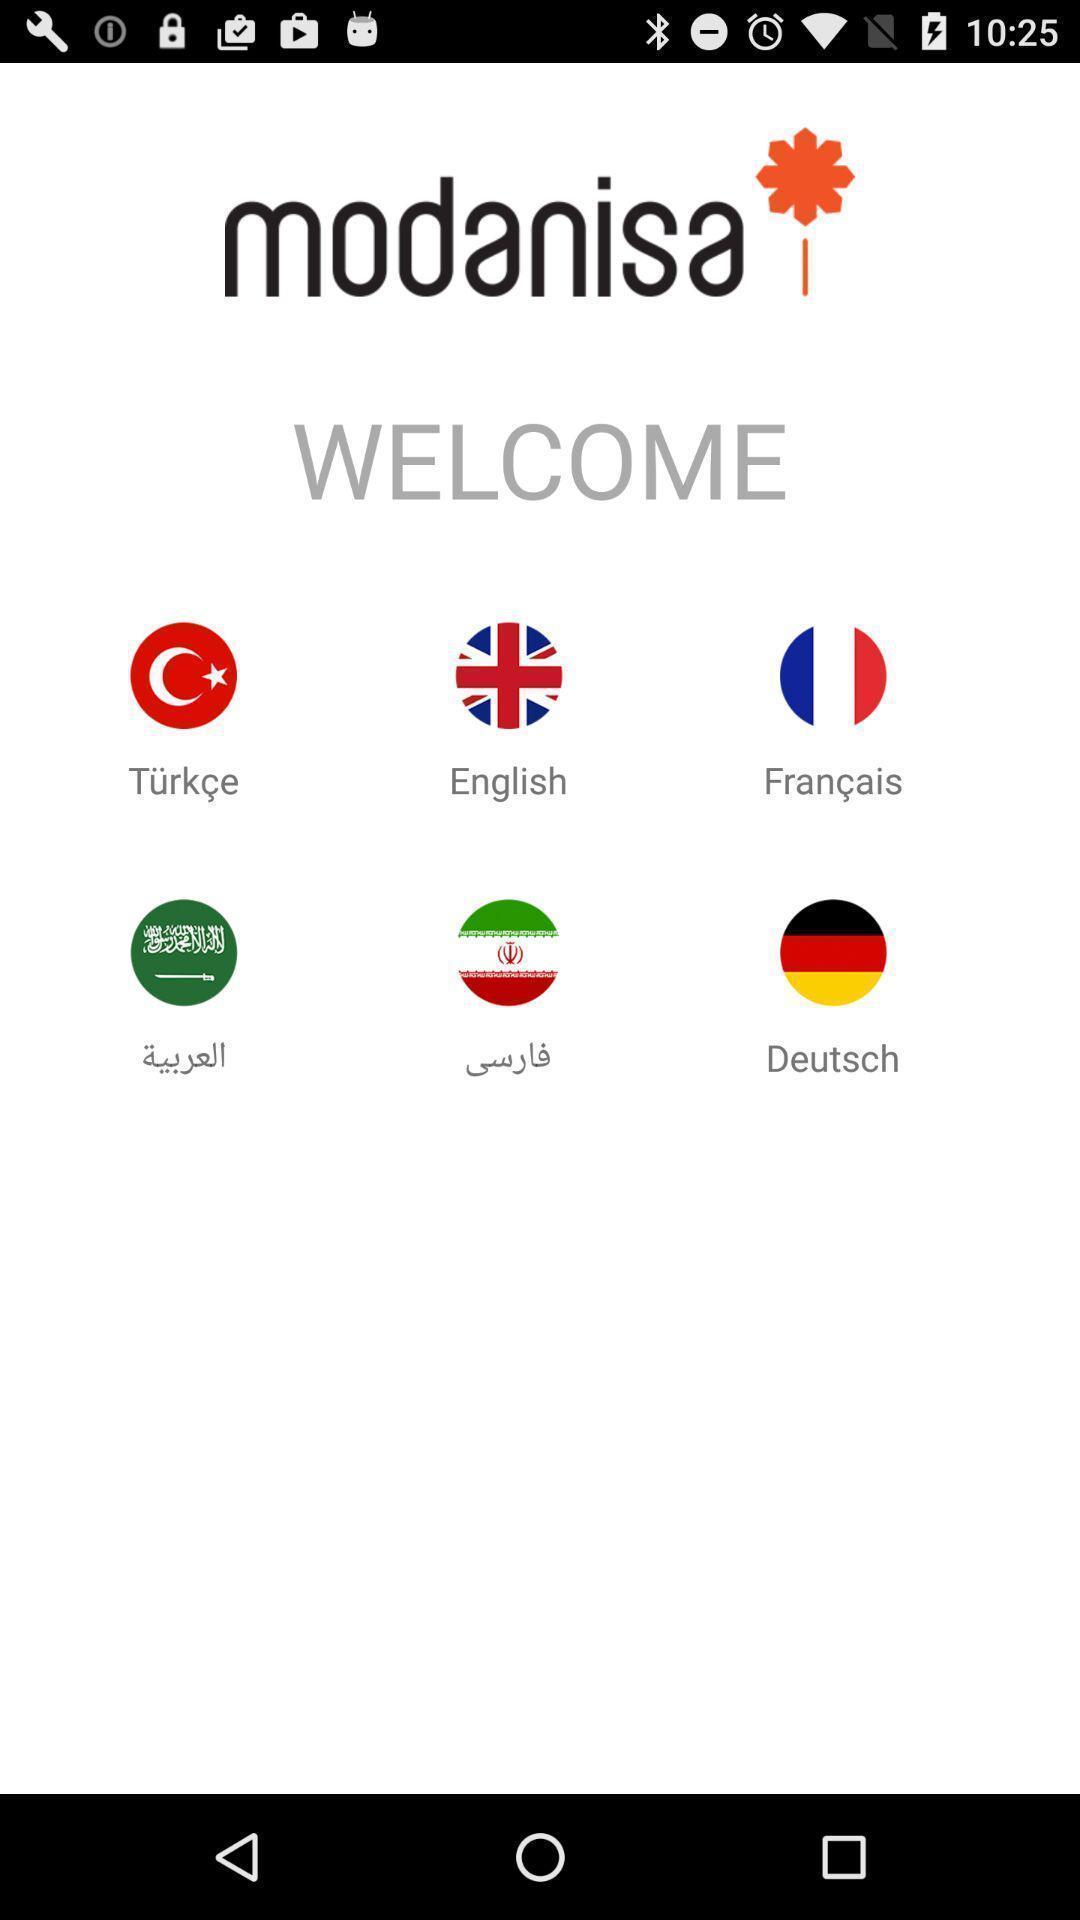What can you discern from this picture? Welcome page with different icons and text in shopping app. 